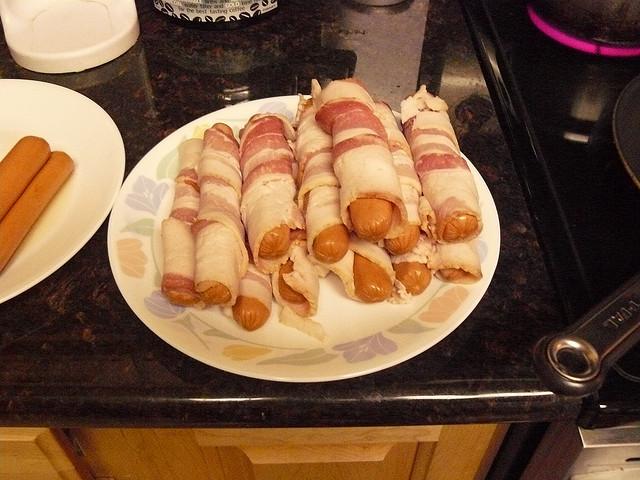Are there any hot dogs that are not wrapped in bacon?
Quick response, please. Yes. How many hot dogs are pictured that are wrapped in bacon?
Short answer required. 12. Is this food cooked?
Short answer required. No. How many plates have food?
Quick response, please. 2. 